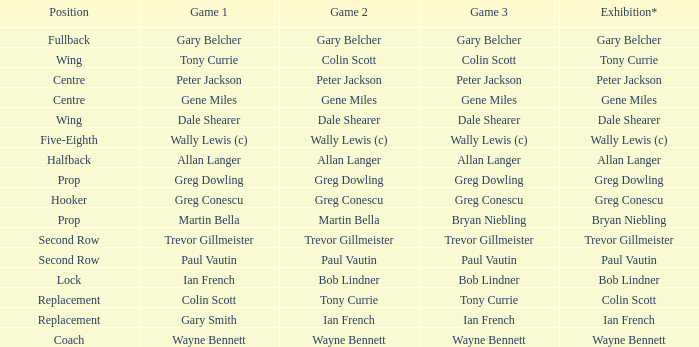In game 1, what is colin scott's position? Replacement. 